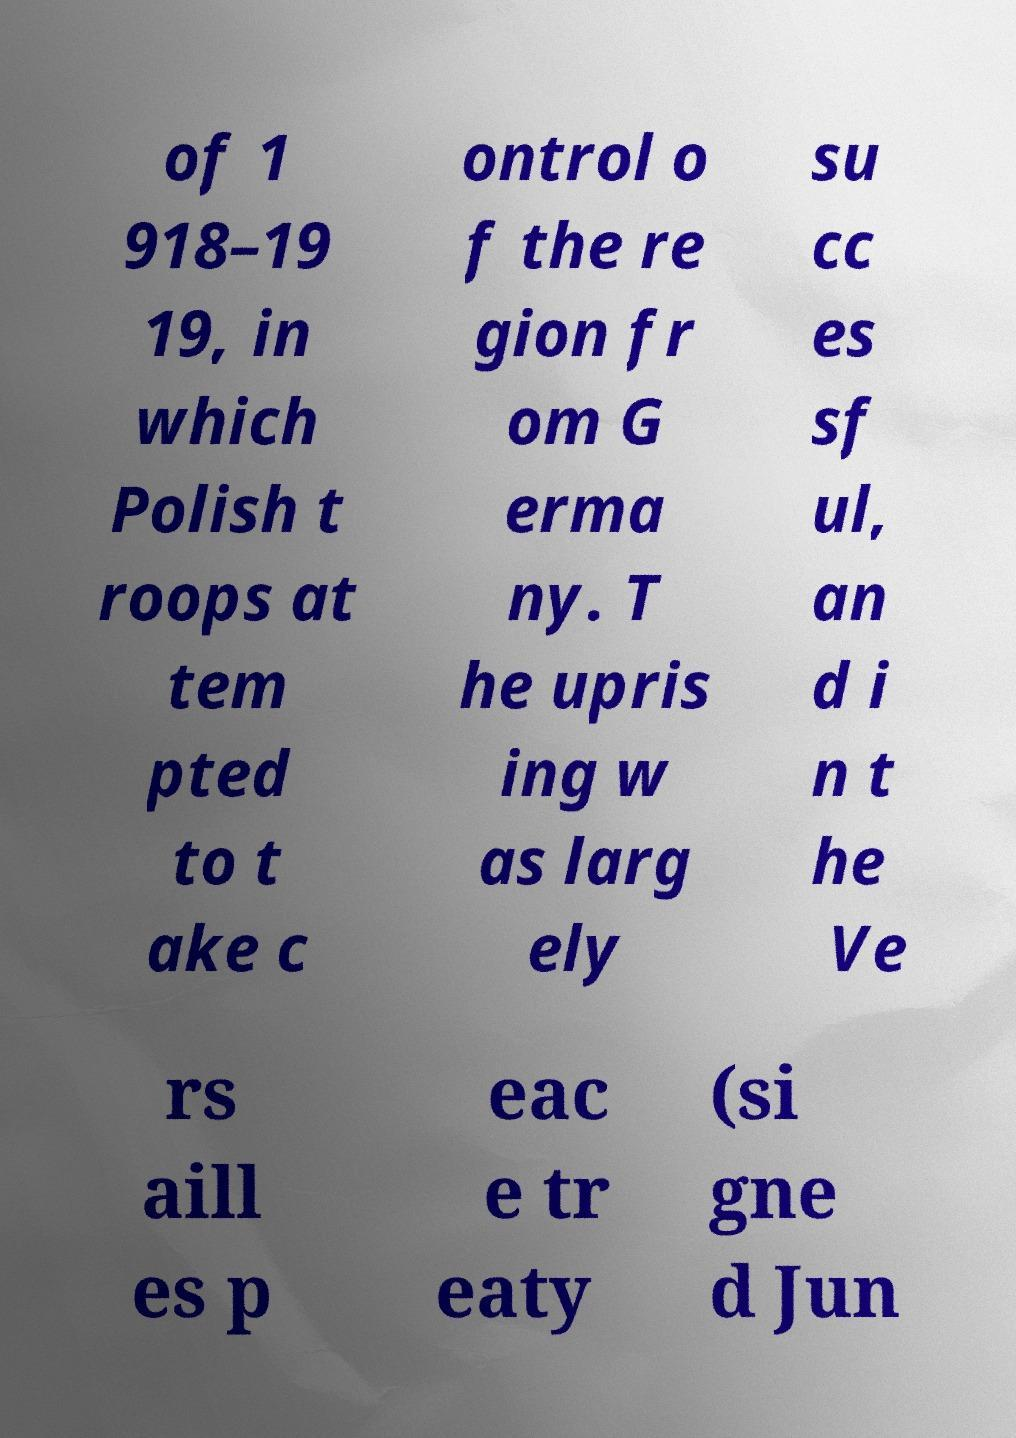For documentation purposes, I need the text within this image transcribed. Could you provide that? of 1 918–19 19, in which Polish t roops at tem pted to t ake c ontrol o f the re gion fr om G erma ny. T he upris ing w as larg ely su cc es sf ul, an d i n t he Ve rs aill es p eac e tr eaty (si gne d Jun 